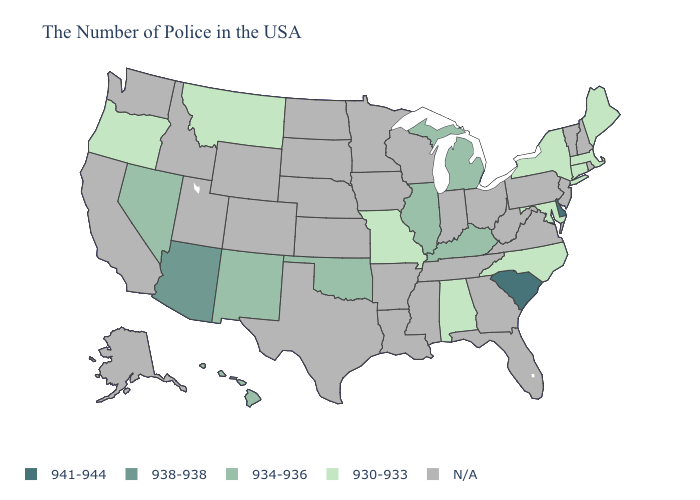Which states have the lowest value in the South?
Answer briefly. Maryland, North Carolina, Alabama. What is the highest value in states that border Mississippi?
Keep it brief. 930-933. Which states have the lowest value in the USA?
Be succinct. Maine, Massachusetts, Connecticut, New York, Maryland, North Carolina, Alabama, Missouri, Montana, Oregon. Is the legend a continuous bar?
Give a very brief answer. No. Name the states that have a value in the range 938-938?
Give a very brief answer. Arizona. Among the states that border West Virginia , which have the highest value?
Short answer required. Kentucky. Does South Carolina have the highest value in the USA?
Concise answer only. Yes. Name the states that have a value in the range N/A?
Write a very short answer. Rhode Island, New Hampshire, Vermont, New Jersey, Pennsylvania, Virginia, West Virginia, Ohio, Florida, Georgia, Indiana, Tennessee, Wisconsin, Mississippi, Louisiana, Arkansas, Minnesota, Iowa, Kansas, Nebraska, Texas, South Dakota, North Dakota, Wyoming, Colorado, Utah, Idaho, California, Washington, Alaska. Name the states that have a value in the range 941-944?
Quick response, please. Delaware, South Carolina. Name the states that have a value in the range N/A?
Answer briefly. Rhode Island, New Hampshire, Vermont, New Jersey, Pennsylvania, Virginia, West Virginia, Ohio, Florida, Georgia, Indiana, Tennessee, Wisconsin, Mississippi, Louisiana, Arkansas, Minnesota, Iowa, Kansas, Nebraska, Texas, South Dakota, North Dakota, Wyoming, Colorado, Utah, Idaho, California, Washington, Alaska. Does North Carolina have the lowest value in the USA?
Be succinct. Yes. 